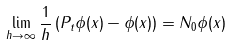Convert formula to latex. <formula><loc_0><loc_0><loc_500><loc_500>\lim _ { h \to \infty } \frac { 1 } { h } \left ( P _ { t } \phi ( x ) - \phi ( x ) \right ) = N _ { 0 } \phi ( x )</formula> 